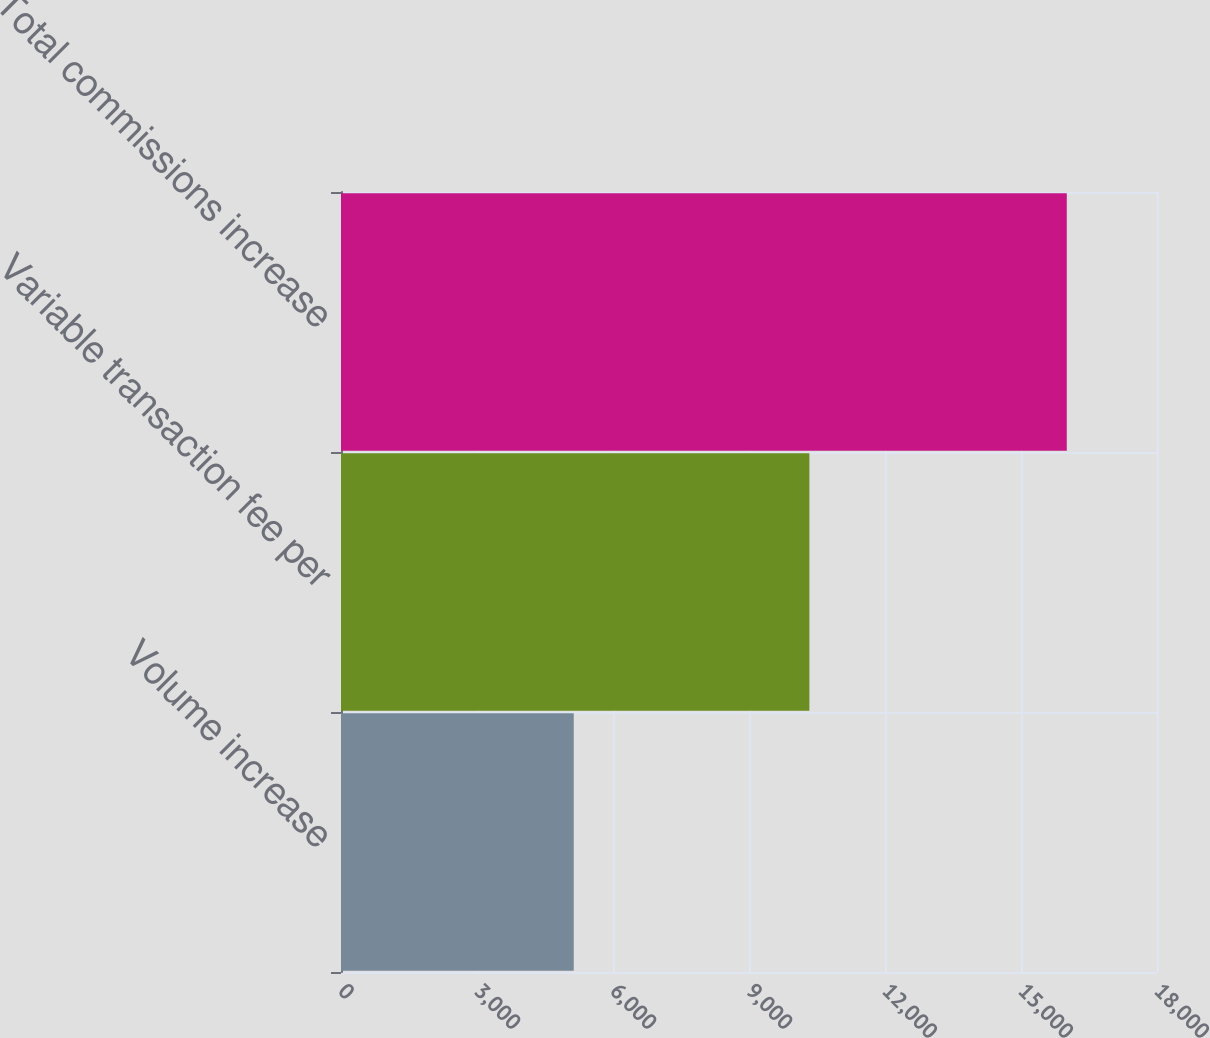Convert chart. <chart><loc_0><loc_0><loc_500><loc_500><bar_chart><fcel>Volume increase<fcel>Variable transaction fee per<fcel>Total commissions increase<nl><fcel>5134<fcel>10332<fcel>16010<nl></chart> 